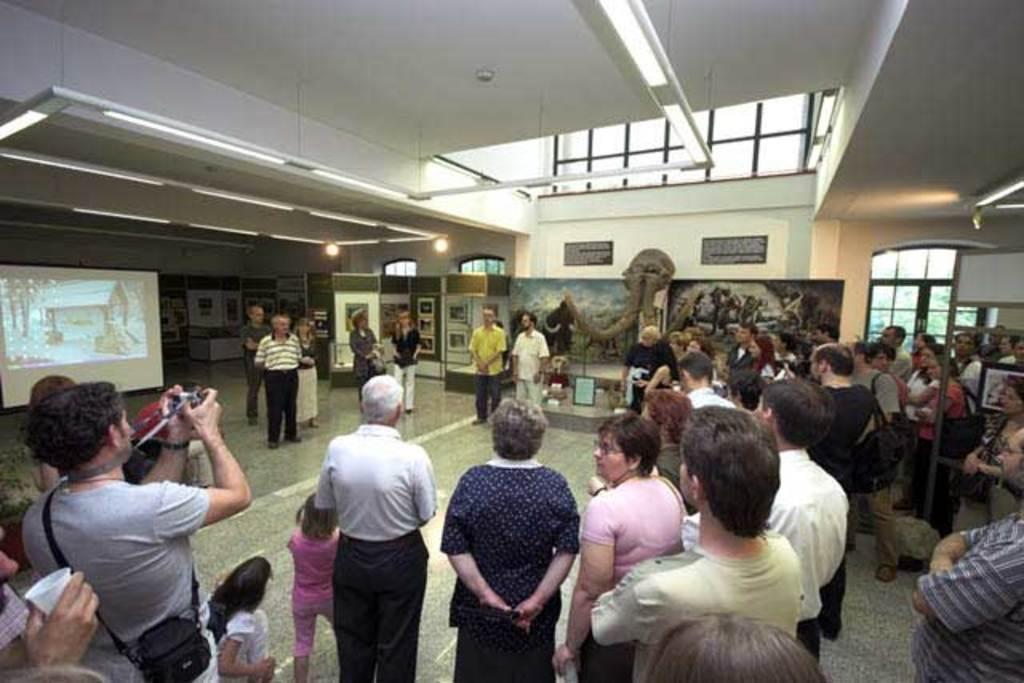Describe this image in one or two sentences. In this picture there are group of people. In the foreground there is a man standing and holding the camera. At the back there is a screen and there are boards on the wall and there might be a statue. On the right side of the image there is a door. Behind the door there are trees. At the top there are lights. At the bottom there is a floor. 